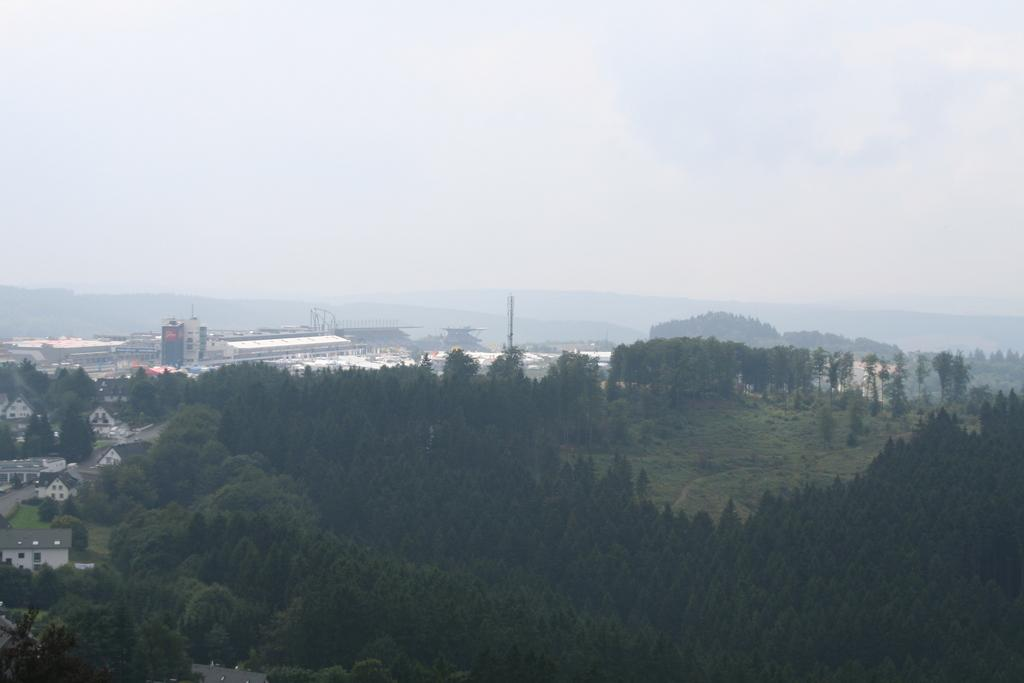What type of vegetation can be seen in the image? There are trees in the image. What type of structures are visible in the image? There are buildings with windows in the image. What type of natural landform can be seen in the image? There are mountains in the image. What type of ground cover is present in the image? There is grass in the image. What is visible in the background of the image? The sky is visible in the background of the image. What type of weather can be inferred from the image? Clouds are present in the sky, suggesting a partly cloudy day. What type of table is visible in the image? There is no table present in the image. How many slopes can be seen in the image? There is no mention of slopes in the image; it features trees, buildings, mountains, grass, sky, and clouds. 